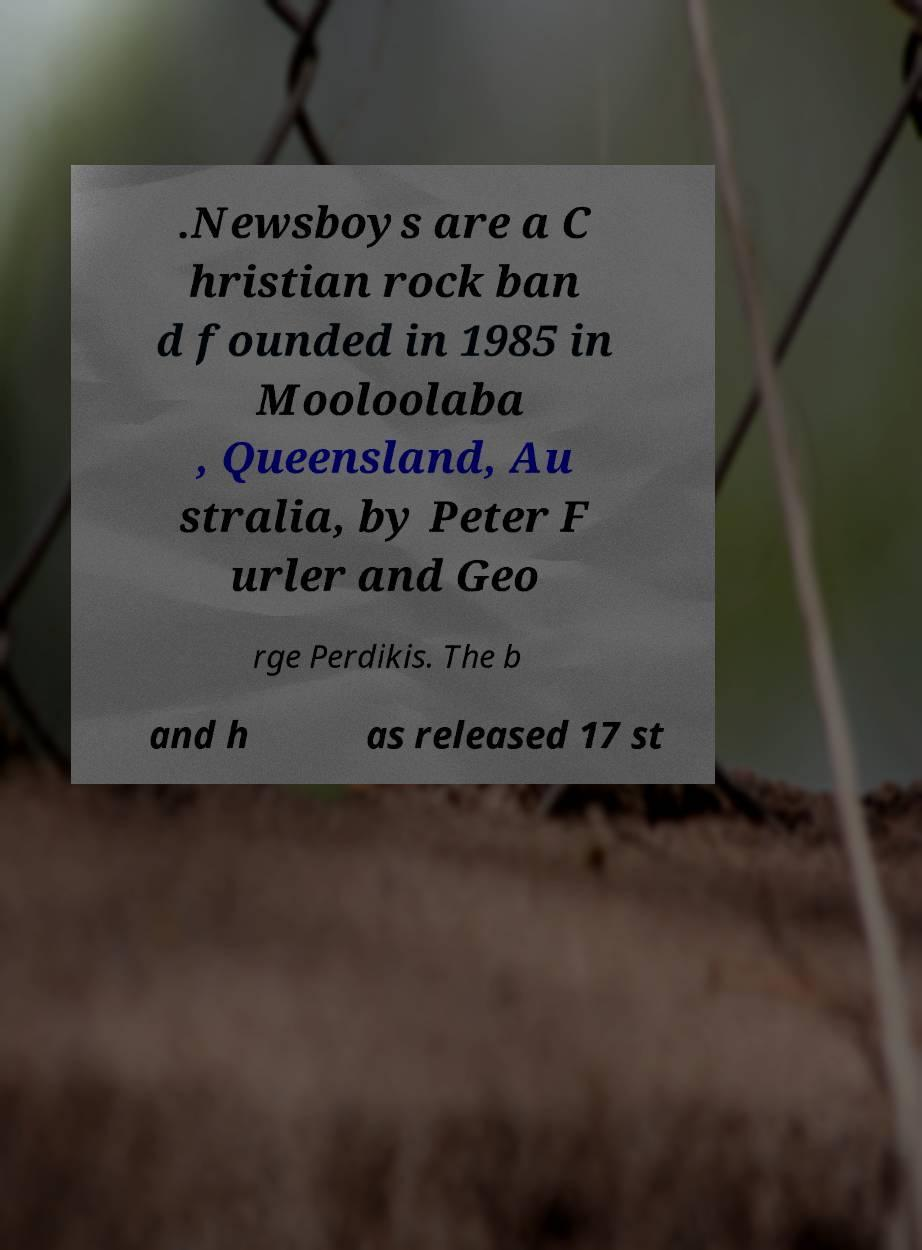Could you extract and type out the text from this image? .Newsboys are a C hristian rock ban d founded in 1985 in Mooloolaba , Queensland, Au stralia, by Peter F urler and Geo rge Perdikis. The b and h as released 17 st 